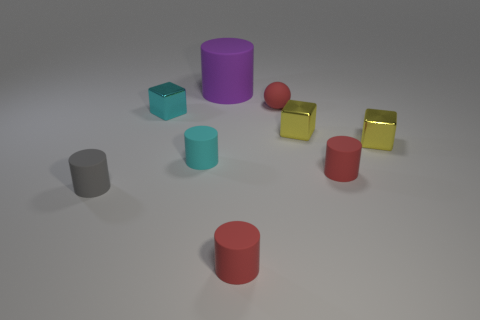How many other things are the same color as the ball?
Offer a very short reply. 2. How many big red things are there?
Give a very brief answer. 0. Is the number of tiny blocks on the left side of the large purple rubber cylinder less than the number of small cubes?
Provide a short and direct response. Yes. Is the material of the tiny cyan cylinder that is to the left of the red matte sphere the same as the tiny gray thing?
Make the answer very short. Yes. What is the shape of the metallic object that is to the left of the red matte object that is in front of the red matte thing that is right of the tiny matte ball?
Provide a succinct answer. Cube. Is there a red matte cylinder that has the same size as the cyan metal thing?
Give a very brief answer. Yes. How big is the purple matte object?
Keep it short and to the point. Large. What number of red spheres have the same size as the gray matte object?
Offer a terse response. 1. Are there fewer cyan objects on the right side of the cyan cylinder than gray things behind the small gray rubber cylinder?
Your answer should be compact. No. There is a cylinder behind the cyan cylinder that is behind the tiny gray object in front of the small cyan rubber cylinder; what is its size?
Your response must be concise. Large. 